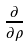Convert formula to latex. <formula><loc_0><loc_0><loc_500><loc_500>\frac { \partial } { \partial \rho }</formula> 